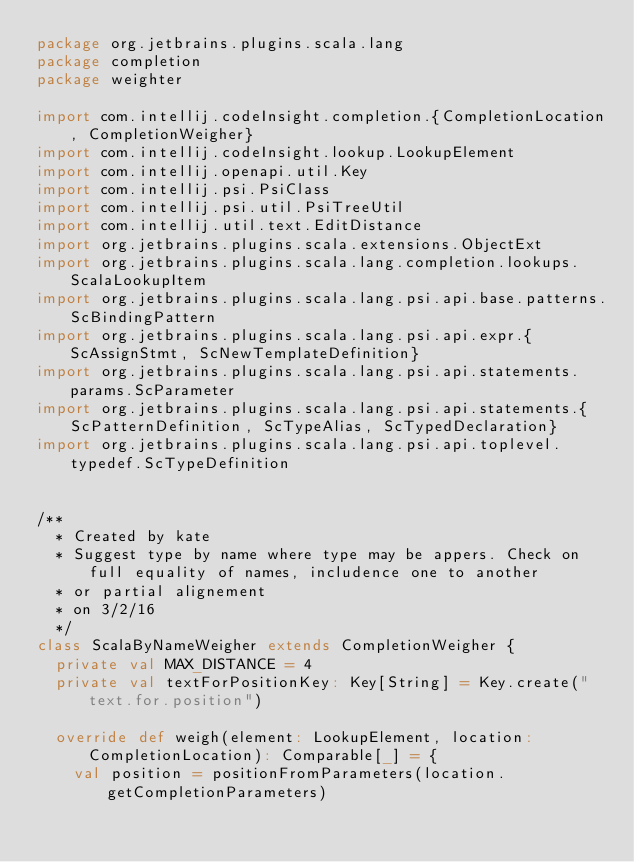Convert code to text. <code><loc_0><loc_0><loc_500><loc_500><_Scala_>package org.jetbrains.plugins.scala.lang
package completion
package weighter

import com.intellij.codeInsight.completion.{CompletionLocation, CompletionWeigher}
import com.intellij.codeInsight.lookup.LookupElement
import com.intellij.openapi.util.Key
import com.intellij.psi.PsiClass
import com.intellij.psi.util.PsiTreeUtil
import com.intellij.util.text.EditDistance
import org.jetbrains.plugins.scala.extensions.ObjectExt
import org.jetbrains.plugins.scala.lang.completion.lookups.ScalaLookupItem
import org.jetbrains.plugins.scala.lang.psi.api.base.patterns.ScBindingPattern
import org.jetbrains.plugins.scala.lang.psi.api.expr.{ScAssignStmt, ScNewTemplateDefinition}
import org.jetbrains.plugins.scala.lang.psi.api.statements.params.ScParameter
import org.jetbrains.plugins.scala.lang.psi.api.statements.{ScPatternDefinition, ScTypeAlias, ScTypedDeclaration}
import org.jetbrains.plugins.scala.lang.psi.api.toplevel.typedef.ScTypeDefinition


/**
  * Created by kate
  * Suggest type by name where type may be appers. Check on full equality of names, includence one to another
  * or partial alignement
  * on 3/2/16
  */
class ScalaByNameWeigher extends CompletionWeigher {
  private val MAX_DISTANCE = 4
  private val textForPositionKey: Key[String] = Key.create("text.for.position")

  override def weigh(element: LookupElement, location: CompletionLocation): Comparable[_] = {
    val position = positionFromParameters(location.getCompletionParameters)</code> 